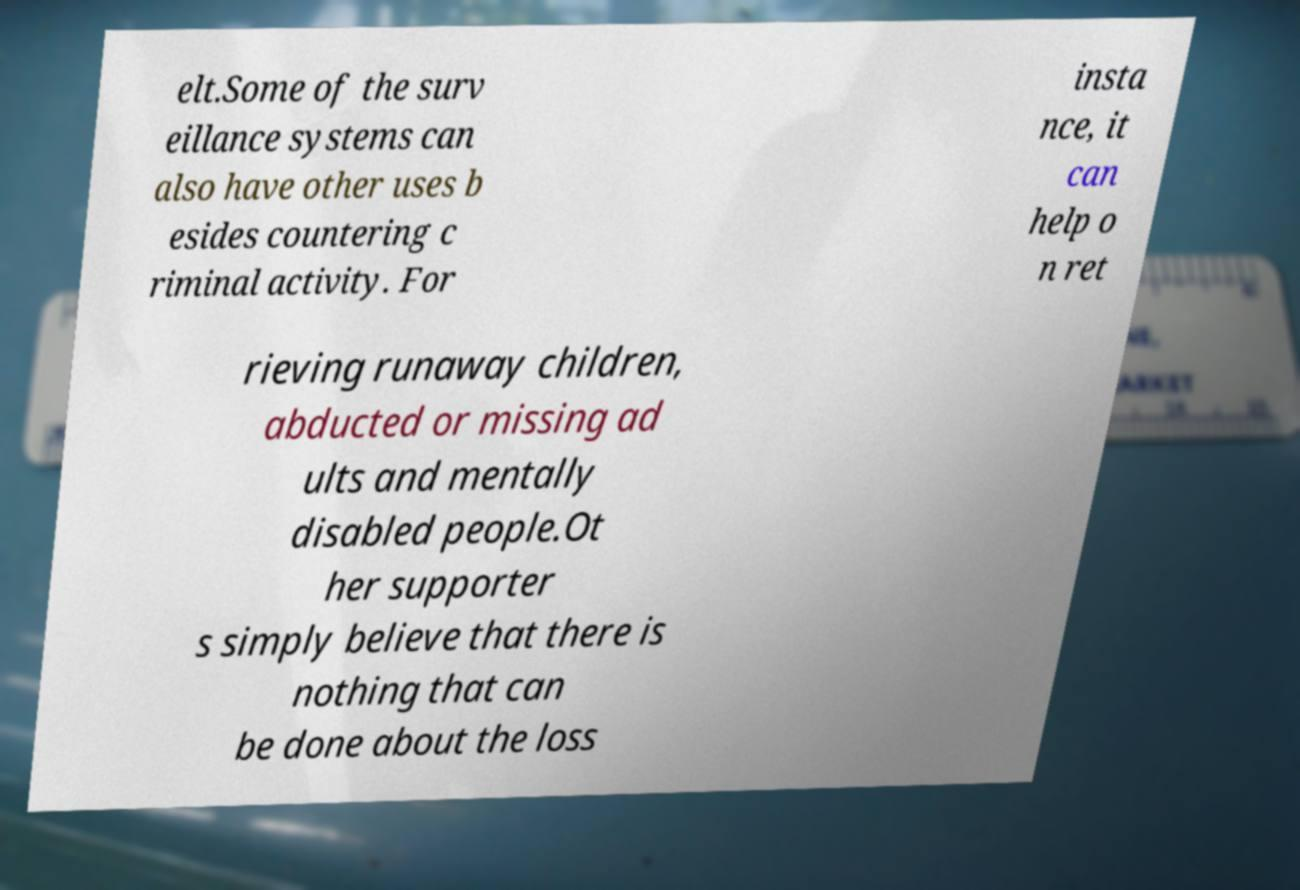Can you accurately transcribe the text from the provided image for me? elt.Some of the surv eillance systems can also have other uses b esides countering c riminal activity. For insta nce, it can help o n ret rieving runaway children, abducted or missing ad ults and mentally disabled people.Ot her supporter s simply believe that there is nothing that can be done about the loss 